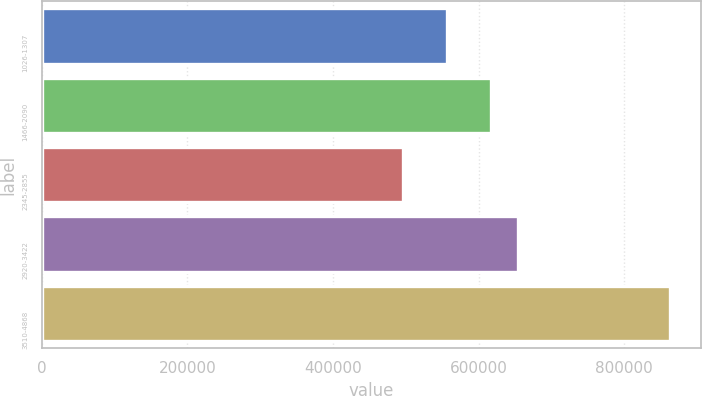Convert chart to OTSL. <chart><loc_0><loc_0><loc_500><loc_500><bar_chart><fcel>1026-1307<fcel>1466-2090<fcel>2345-2855<fcel>2920-3422<fcel>3510-4868<nl><fcel>556478<fcel>617788<fcel>496815<fcel>654417<fcel>863108<nl></chart> 